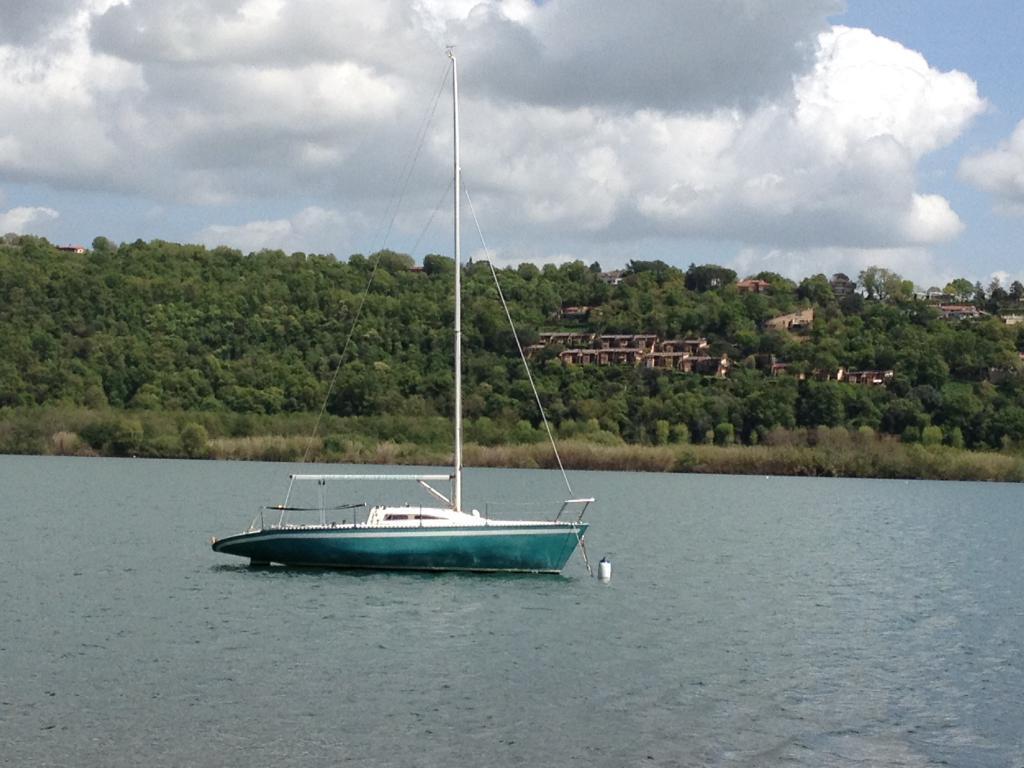In one or two sentences, can you explain what this image depicts? In this image, we can see water, there is a ship on the water, we can see some green trees, there are some homes, at the top there is a sky and we can see some clouds. 